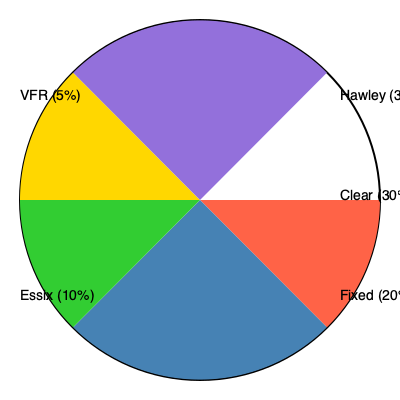Based on the pie chart showing success rates of different orthodontic retention methods, which method demonstrates the highest success rate, and by what percentage does it outperform the second most successful method? To answer this question, we need to follow these steps:

1. Identify the retention methods and their success rates from the pie chart:
   - Hawley: 35%
   - Clear: 30%
   - Fixed: 20%
   - Essix: 10%
   - VFR (Vacuum-Formed Retainer): 5%

2. Determine the method with the highest success rate:
   The Hawley retainer has the highest success rate at 35%.

3. Identify the second most successful method:
   The Clear retainer has the second-highest success rate at 30%.

4. Calculate the difference between the top two methods:
   $35\% - 30\% = 5\%$

Therefore, the Hawley retainer outperforms the Clear retainer by 5 percentage points.

It's important to note that this data challenges some recent research suggesting that clear aligners and vacuum-formed retainers might be more effective than traditional Hawley retainers. As a renowned orthodontist, you might want to critically examine the methodology and sample size of the study that produced these results, as they seem to contradict some current trends in orthodontic retention practices.
Answer: Hawley retainer, by 5 percentage points 